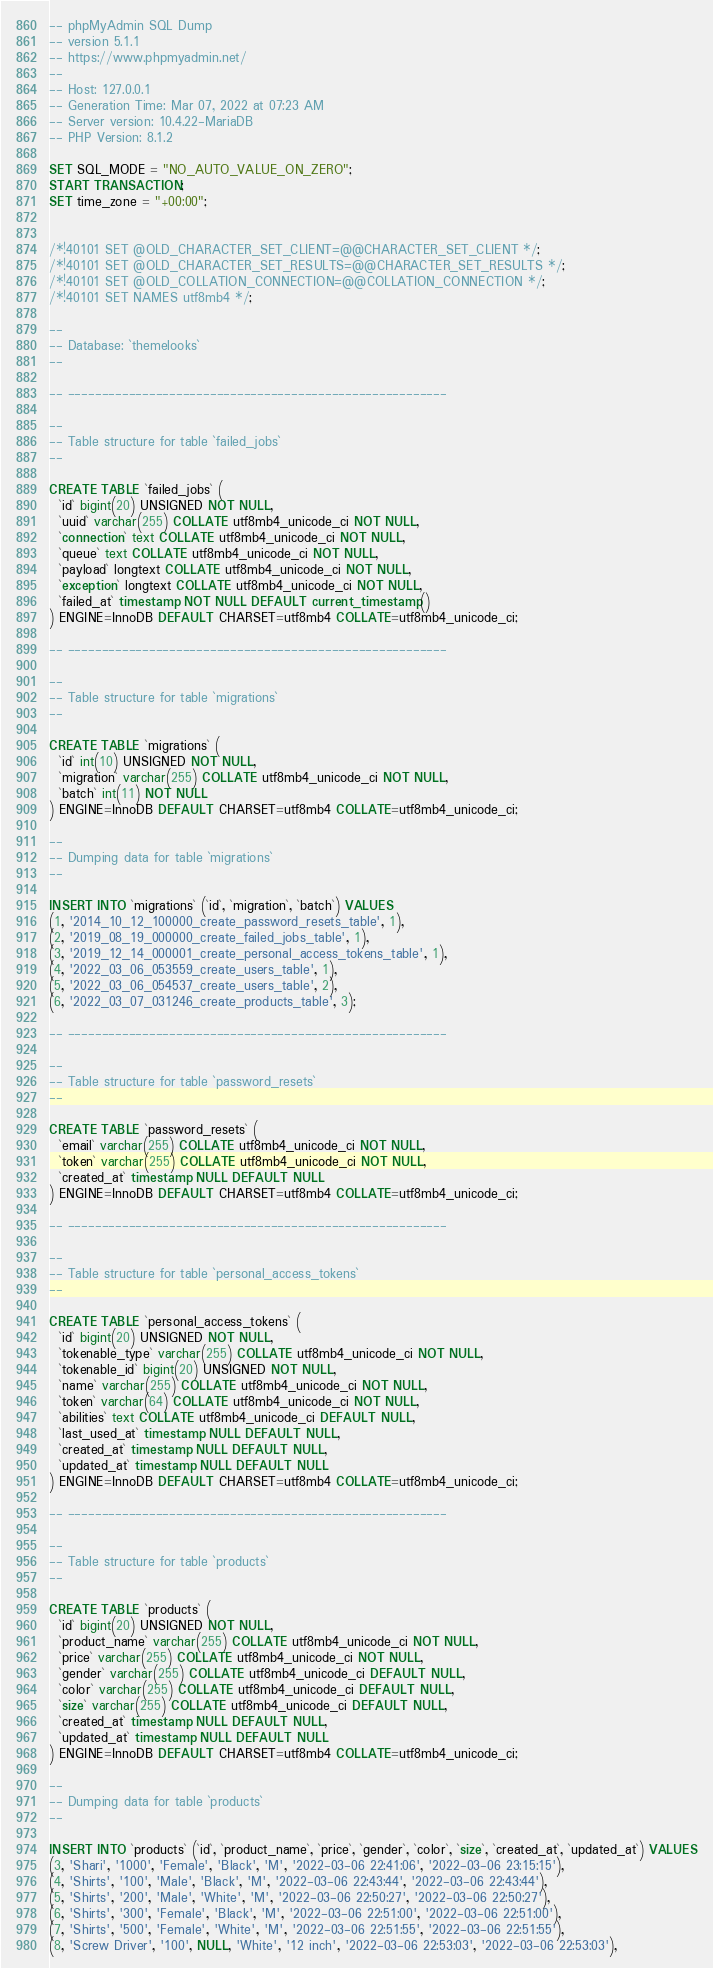Convert code to text. <code><loc_0><loc_0><loc_500><loc_500><_SQL_>-- phpMyAdmin SQL Dump
-- version 5.1.1
-- https://www.phpmyadmin.net/
--
-- Host: 127.0.0.1
-- Generation Time: Mar 07, 2022 at 07:23 AM
-- Server version: 10.4.22-MariaDB
-- PHP Version: 8.1.2

SET SQL_MODE = "NO_AUTO_VALUE_ON_ZERO";
START TRANSACTION;
SET time_zone = "+00:00";


/*!40101 SET @OLD_CHARACTER_SET_CLIENT=@@CHARACTER_SET_CLIENT */;
/*!40101 SET @OLD_CHARACTER_SET_RESULTS=@@CHARACTER_SET_RESULTS */;
/*!40101 SET @OLD_COLLATION_CONNECTION=@@COLLATION_CONNECTION */;
/*!40101 SET NAMES utf8mb4 */;

--
-- Database: `themelooks`
--

-- --------------------------------------------------------

--
-- Table structure for table `failed_jobs`
--

CREATE TABLE `failed_jobs` (
  `id` bigint(20) UNSIGNED NOT NULL,
  `uuid` varchar(255) COLLATE utf8mb4_unicode_ci NOT NULL,
  `connection` text COLLATE utf8mb4_unicode_ci NOT NULL,
  `queue` text COLLATE utf8mb4_unicode_ci NOT NULL,
  `payload` longtext COLLATE utf8mb4_unicode_ci NOT NULL,
  `exception` longtext COLLATE utf8mb4_unicode_ci NOT NULL,
  `failed_at` timestamp NOT NULL DEFAULT current_timestamp()
) ENGINE=InnoDB DEFAULT CHARSET=utf8mb4 COLLATE=utf8mb4_unicode_ci;

-- --------------------------------------------------------

--
-- Table structure for table `migrations`
--

CREATE TABLE `migrations` (
  `id` int(10) UNSIGNED NOT NULL,
  `migration` varchar(255) COLLATE utf8mb4_unicode_ci NOT NULL,
  `batch` int(11) NOT NULL
) ENGINE=InnoDB DEFAULT CHARSET=utf8mb4 COLLATE=utf8mb4_unicode_ci;

--
-- Dumping data for table `migrations`
--

INSERT INTO `migrations` (`id`, `migration`, `batch`) VALUES
(1, '2014_10_12_100000_create_password_resets_table', 1),
(2, '2019_08_19_000000_create_failed_jobs_table', 1),
(3, '2019_12_14_000001_create_personal_access_tokens_table', 1),
(4, '2022_03_06_053559_create_users_table', 1),
(5, '2022_03_06_054537_create_users_table', 2),
(6, '2022_03_07_031246_create_products_table', 3);

-- --------------------------------------------------------

--
-- Table structure for table `password_resets`
--

CREATE TABLE `password_resets` (
  `email` varchar(255) COLLATE utf8mb4_unicode_ci NOT NULL,
  `token` varchar(255) COLLATE utf8mb4_unicode_ci NOT NULL,
  `created_at` timestamp NULL DEFAULT NULL
) ENGINE=InnoDB DEFAULT CHARSET=utf8mb4 COLLATE=utf8mb4_unicode_ci;

-- --------------------------------------------------------

--
-- Table structure for table `personal_access_tokens`
--

CREATE TABLE `personal_access_tokens` (
  `id` bigint(20) UNSIGNED NOT NULL,
  `tokenable_type` varchar(255) COLLATE utf8mb4_unicode_ci NOT NULL,
  `tokenable_id` bigint(20) UNSIGNED NOT NULL,
  `name` varchar(255) COLLATE utf8mb4_unicode_ci NOT NULL,
  `token` varchar(64) COLLATE utf8mb4_unicode_ci NOT NULL,
  `abilities` text COLLATE utf8mb4_unicode_ci DEFAULT NULL,
  `last_used_at` timestamp NULL DEFAULT NULL,
  `created_at` timestamp NULL DEFAULT NULL,
  `updated_at` timestamp NULL DEFAULT NULL
) ENGINE=InnoDB DEFAULT CHARSET=utf8mb4 COLLATE=utf8mb4_unicode_ci;

-- --------------------------------------------------------

--
-- Table structure for table `products`
--

CREATE TABLE `products` (
  `id` bigint(20) UNSIGNED NOT NULL,
  `product_name` varchar(255) COLLATE utf8mb4_unicode_ci NOT NULL,
  `price` varchar(255) COLLATE utf8mb4_unicode_ci NOT NULL,
  `gender` varchar(255) COLLATE utf8mb4_unicode_ci DEFAULT NULL,
  `color` varchar(255) COLLATE utf8mb4_unicode_ci DEFAULT NULL,
  `size` varchar(255) COLLATE utf8mb4_unicode_ci DEFAULT NULL,
  `created_at` timestamp NULL DEFAULT NULL,
  `updated_at` timestamp NULL DEFAULT NULL
) ENGINE=InnoDB DEFAULT CHARSET=utf8mb4 COLLATE=utf8mb4_unicode_ci;

--
-- Dumping data for table `products`
--

INSERT INTO `products` (`id`, `product_name`, `price`, `gender`, `color`, `size`, `created_at`, `updated_at`) VALUES
(3, 'Shari', '1000', 'Female', 'Black', 'M', '2022-03-06 22:41:06', '2022-03-06 23:15:15'),
(4, 'Shirts', '100', 'Male', 'Black', 'M', '2022-03-06 22:43:44', '2022-03-06 22:43:44'),
(5, 'Shirts', '200', 'Male', 'White', 'M', '2022-03-06 22:50:27', '2022-03-06 22:50:27'),
(6, 'Shirts', '300', 'Female', 'Black', 'M', '2022-03-06 22:51:00', '2022-03-06 22:51:00'),
(7, 'Shirts', '500', 'Female', 'White', 'M', '2022-03-06 22:51:55', '2022-03-06 22:51:55'),
(8, 'Screw Driver', '100', NULL, 'White', '12 inch', '2022-03-06 22:53:03', '2022-03-06 22:53:03'),</code> 